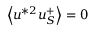<formula> <loc_0><loc_0><loc_500><loc_500>\left < u ^ { * 2 } u _ { S } ^ { + } \right > = 0</formula> 